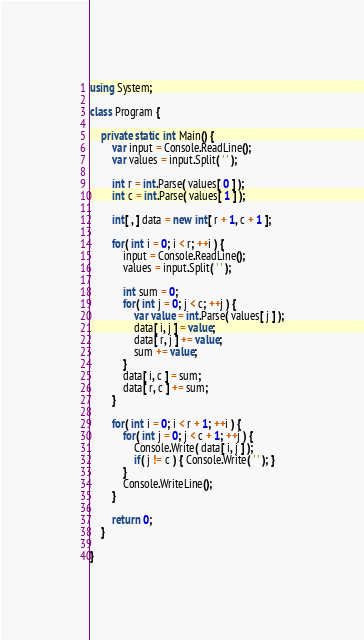Convert code to text. <code><loc_0><loc_0><loc_500><loc_500><_C#_>using System;

class Program {

    private static int Main() {
        var input = Console.ReadLine();
        var values = input.Split( ' ' );

        int r = int.Parse( values[ 0 ] );
        int c = int.Parse( values[ 1 ] );

        int[ , ] data = new int[ r + 1, c + 1 ];

        for( int i = 0; i < r; ++i ) {
            input = Console.ReadLine();
            values = input.Split( ' ' );

            int sum = 0;
            for( int j = 0; j < c; ++j ) {
                var value = int.Parse( values[ j ] );
                data[ i, j ] = value;
                data[ r, j ] += value;
                sum += value;
            }
            data[ i, c ] = sum;
            data[ r, c ] += sum;
        }

        for( int i = 0; i < r + 1; ++i ) {
            for( int j = 0; j < c + 1; ++j ) {
                Console.Write( data[ i, j ] );
                if( j != c ) { Console.Write( ' ' ); }
            }
            Console.WriteLine();
        }

        return 0;
    }

}</code> 